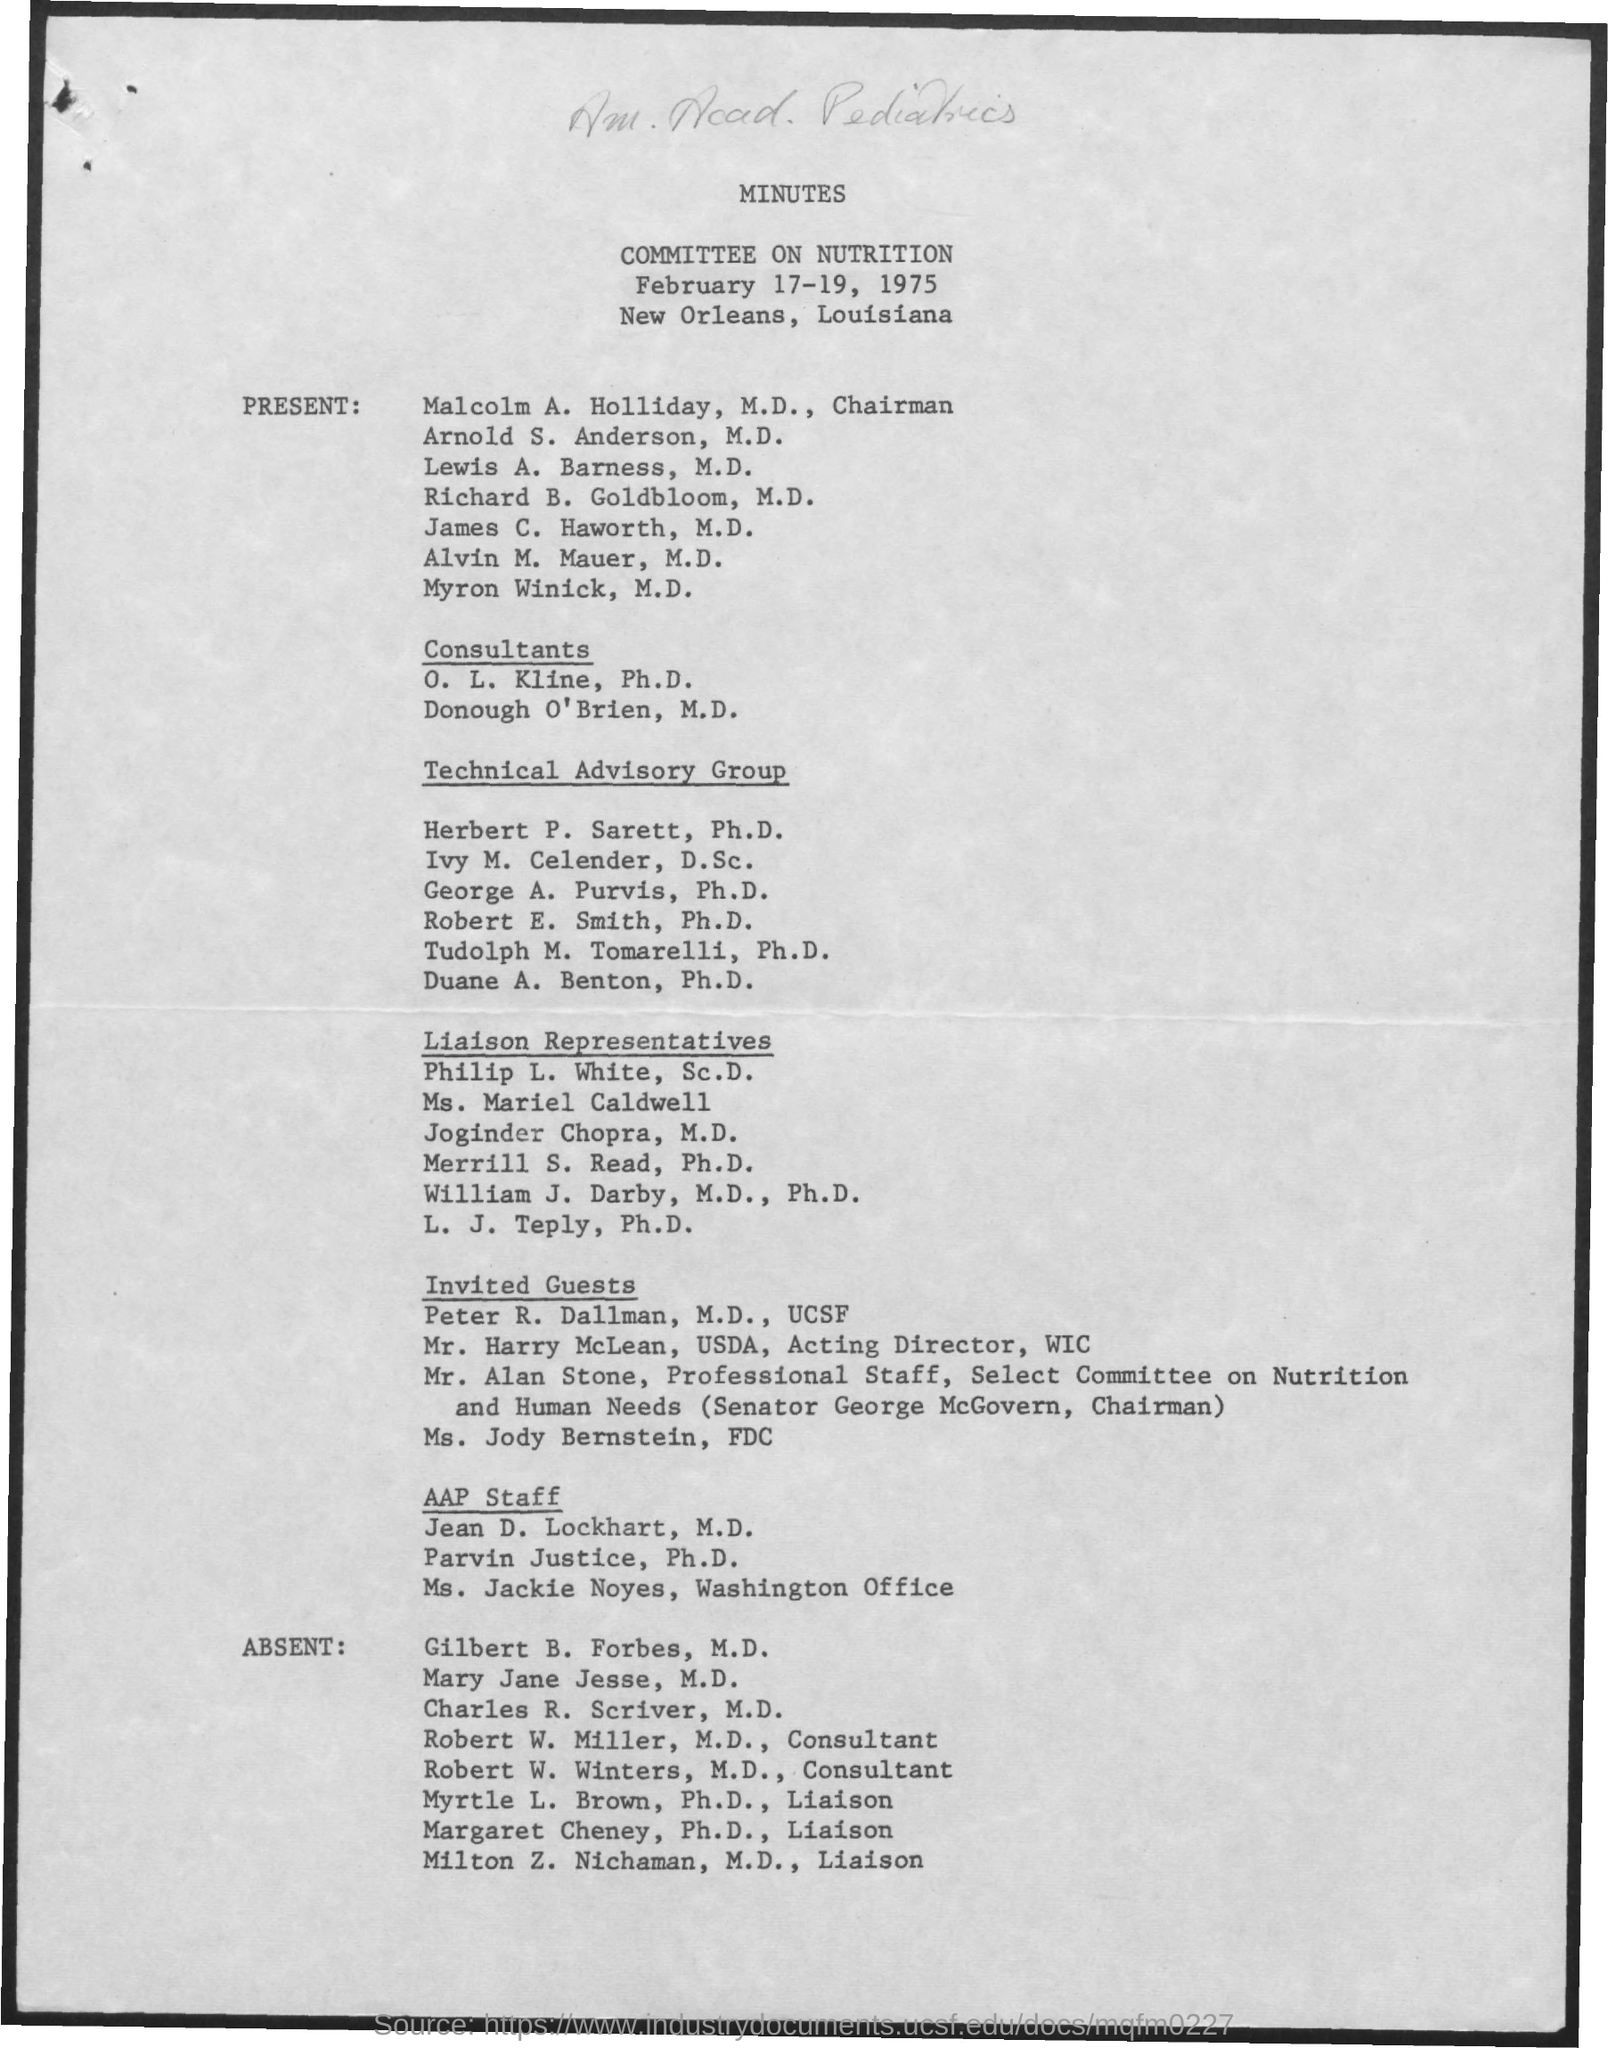What is the first title which is not handwritten?
Ensure brevity in your answer.  Minutes. What is the second title which is not handwritten?
Make the answer very short. Committee on Nutrition. Who is the Chairman?
Ensure brevity in your answer.  Malcolm A. Holliday, M.D. What is the designation of Robert W. Miller?
Your answer should be compact. Consultant. What is the designation of Robert W. Winters?
Provide a succinct answer. Consultant. 